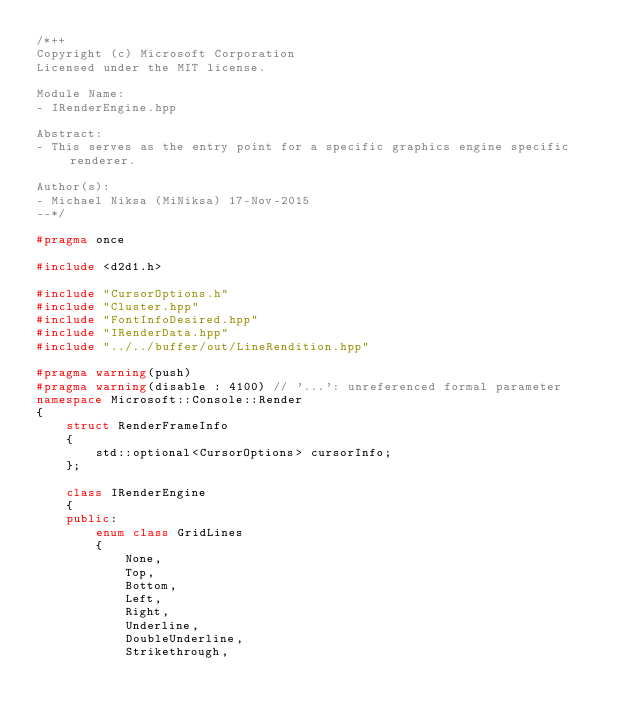Convert code to text. <code><loc_0><loc_0><loc_500><loc_500><_C++_>/*++
Copyright (c) Microsoft Corporation
Licensed under the MIT license.

Module Name:
- IRenderEngine.hpp

Abstract:
- This serves as the entry point for a specific graphics engine specific renderer.

Author(s):
- Michael Niksa (MiNiksa) 17-Nov-2015
--*/

#pragma once

#include <d2d1.h>

#include "CursorOptions.h"
#include "Cluster.hpp"
#include "FontInfoDesired.hpp"
#include "IRenderData.hpp"
#include "../../buffer/out/LineRendition.hpp"

#pragma warning(push)
#pragma warning(disable : 4100) // '...': unreferenced formal parameter
namespace Microsoft::Console::Render
{
    struct RenderFrameInfo
    {
        std::optional<CursorOptions> cursorInfo;
    };

    class IRenderEngine
    {
    public:
        enum class GridLines
        {
            None,
            Top,
            Bottom,
            Left,
            Right,
            Underline,
            DoubleUnderline,
            Strikethrough,</code> 